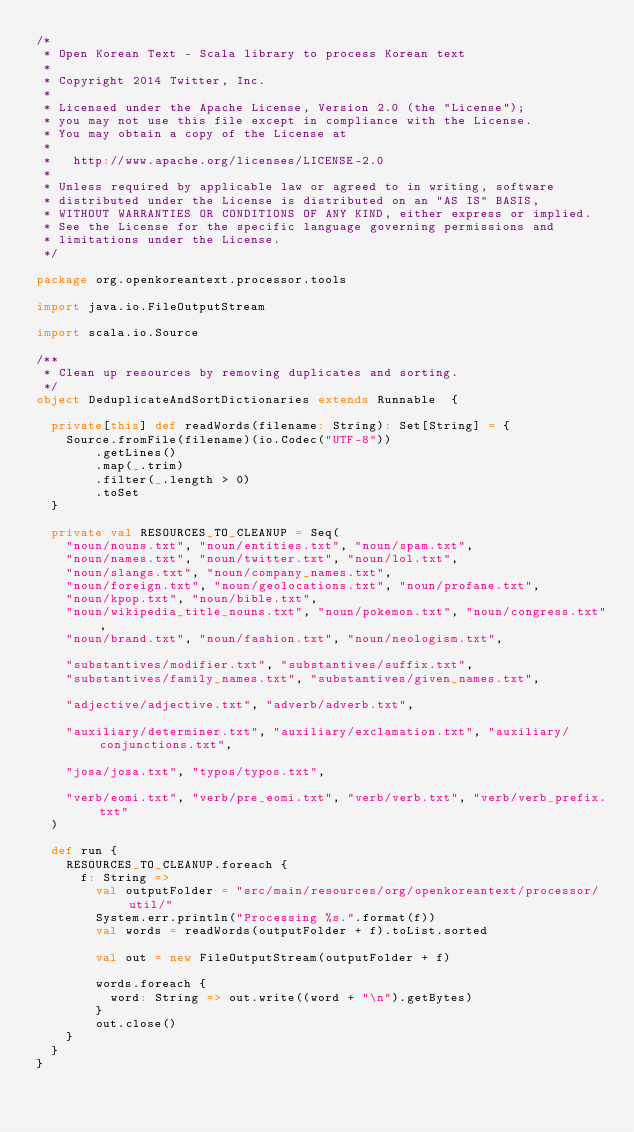Convert code to text. <code><loc_0><loc_0><loc_500><loc_500><_Scala_>/*
 * Open Korean Text - Scala library to process Korean text
 *
 * Copyright 2014 Twitter, Inc.
 *
 * Licensed under the Apache License, Version 2.0 (the "License");
 * you may not use this file except in compliance with the License.
 * You may obtain a copy of the License at
 *
 *   http://www.apache.org/licenses/LICENSE-2.0
 *
 * Unless required by applicable law or agreed to in writing, software
 * distributed under the License is distributed on an "AS IS" BASIS,
 * WITHOUT WARRANTIES OR CONDITIONS OF ANY KIND, either express or implied.
 * See the License for the specific language governing permissions and
 * limitations under the License.
 */

package org.openkoreantext.processor.tools

import java.io.FileOutputStream

import scala.io.Source

/**
 * Clean up resources by removing duplicates and sorting.
 */
object DeduplicateAndSortDictionaries extends Runnable  {

  private[this] def readWords(filename: String): Set[String] = {
    Source.fromFile(filename)(io.Codec("UTF-8"))
        .getLines()
        .map(_.trim)
        .filter(_.length > 0)
        .toSet
  }

  private val RESOURCES_TO_CLEANUP = Seq(
    "noun/nouns.txt", "noun/entities.txt", "noun/spam.txt",
    "noun/names.txt", "noun/twitter.txt", "noun/lol.txt",
    "noun/slangs.txt", "noun/company_names.txt",
    "noun/foreign.txt", "noun/geolocations.txt", "noun/profane.txt",
    "noun/kpop.txt", "noun/bible.txt",
    "noun/wikipedia_title_nouns.txt", "noun/pokemon.txt", "noun/congress.txt",
    "noun/brand.txt", "noun/fashion.txt", "noun/neologism.txt",

    "substantives/modifier.txt", "substantives/suffix.txt",
    "substantives/family_names.txt", "substantives/given_names.txt",

    "adjective/adjective.txt", "adverb/adverb.txt",

    "auxiliary/determiner.txt", "auxiliary/exclamation.txt", "auxiliary/conjunctions.txt",

    "josa/josa.txt", "typos/typos.txt",

    "verb/eomi.txt", "verb/pre_eomi.txt", "verb/verb.txt", "verb/verb_prefix.txt"
  )

  def run {
    RESOURCES_TO_CLEANUP.foreach {
      f: String =>
        val outputFolder = "src/main/resources/org/openkoreantext/processor/util/"
        System.err.println("Processing %s.".format(f))
        val words = readWords(outputFolder + f).toList.sorted

        val out = new FileOutputStream(outputFolder + f)

        words.foreach {
          word: String => out.write((word + "\n").getBytes)
        }
        out.close()
    }
  }
}
</code> 